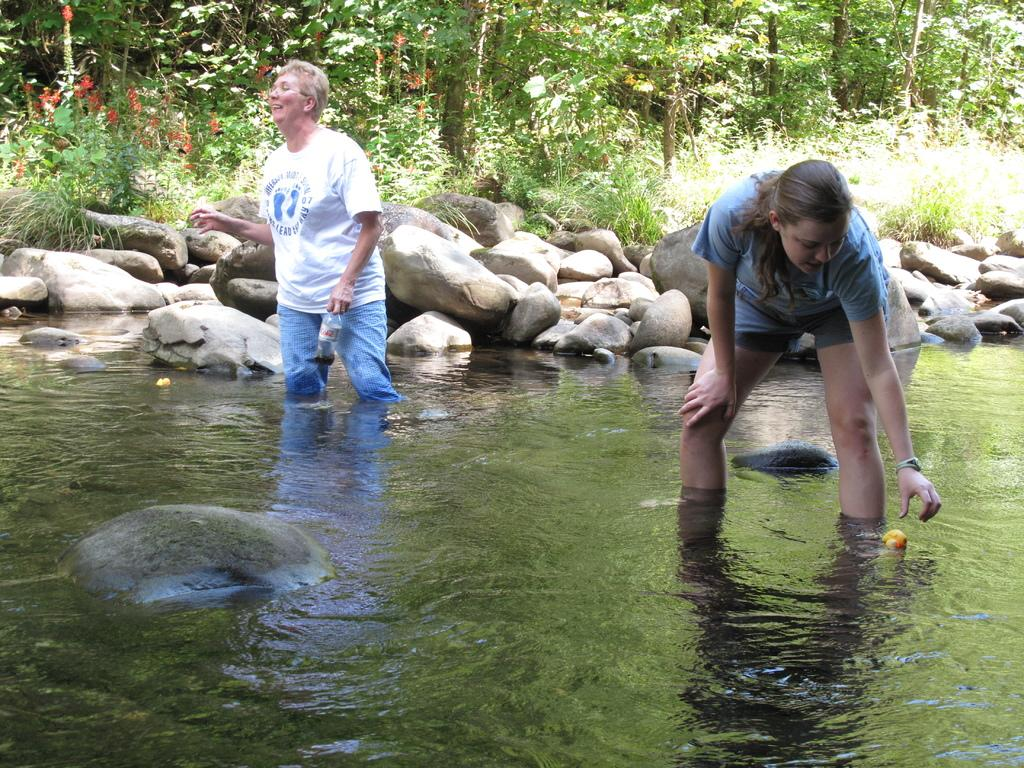What are the two women in the image doing? The two women are standing in the water. What can be seen behind the women? There are stones visible behind the women. What type of vegetation is present in the image? There are plants in the image. What is visible in the background of the image? There are trees in the background of the image. What songs are the women singing while standing in the water? There is no indication in the image that the women are singing songs, so it cannot be determined from the picture. 